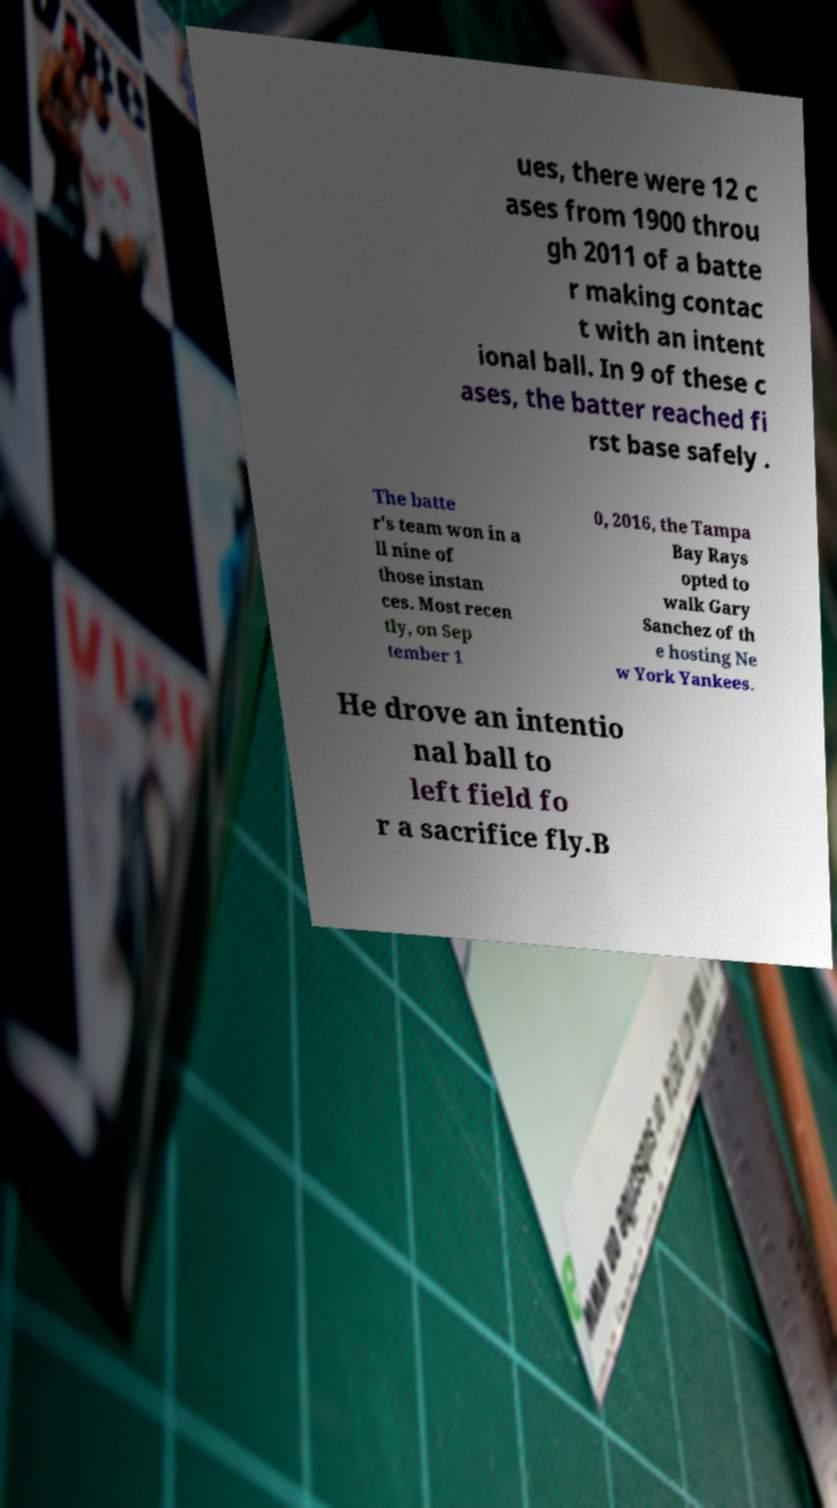There's text embedded in this image that I need extracted. Can you transcribe it verbatim? ues, there were 12 c ases from 1900 throu gh 2011 of a batte r making contac t with an intent ional ball. In 9 of these c ases, the batter reached fi rst base safely . The batte r's team won in a ll nine of those instan ces. Most recen tly, on Sep tember 1 0, 2016, the Tampa Bay Rays opted to walk Gary Sanchez of th e hosting Ne w York Yankees. He drove an intentio nal ball to left field fo r a sacrifice fly.B 